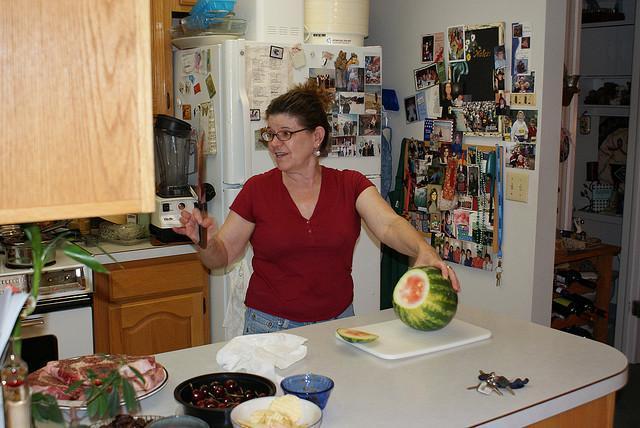How many melons are on display?
Give a very brief answer. 1. How many bowls are visible?
Give a very brief answer. 2. How many potted plants are there?
Give a very brief answer. 2. How many zebras are in the photo?
Give a very brief answer. 0. 